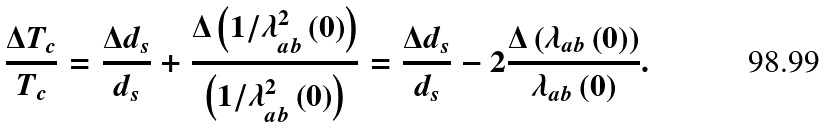<formula> <loc_0><loc_0><loc_500><loc_500>\frac { \Delta T _ { c } } { T _ { c } } = \frac { \Delta d _ { s } } { d _ { s } } + \frac { \Delta \left ( 1 / \lambda _ { a b } ^ { 2 } \left ( 0 \right ) \right ) } { \left ( 1 / \lambda _ { a b } ^ { 2 } \left ( 0 \right ) \right ) } = \frac { \Delta d _ { s } } { d _ { s } } - 2 \frac { \Delta \left ( \lambda _ { a b } \left ( 0 \right ) \right ) } { \lambda _ { a b } \left ( 0 \right ) } .</formula> 